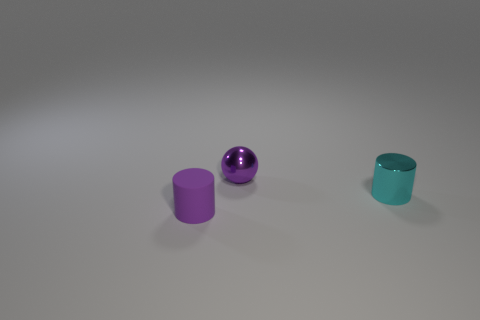Add 2 gray shiny things. How many objects exist? 5 Subtract all cylinders. How many objects are left? 1 Add 2 tiny metallic things. How many tiny metallic things are left? 4 Add 1 big purple metal cylinders. How many big purple metal cylinders exist? 1 Subtract 0 yellow balls. How many objects are left? 3 Subtract all big green shiny things. Subtract all matte objects. How many objects are left? 2 